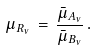<formula> <loc_0><loc_0><loc_500><loc_500>\mu _ { R _ { \nu } } \, = \, \frac { \bar { \mu } _ { A _ { \nu } } } { \bar { \mu } _ { B _ { \nu } } } \, .</formula> 